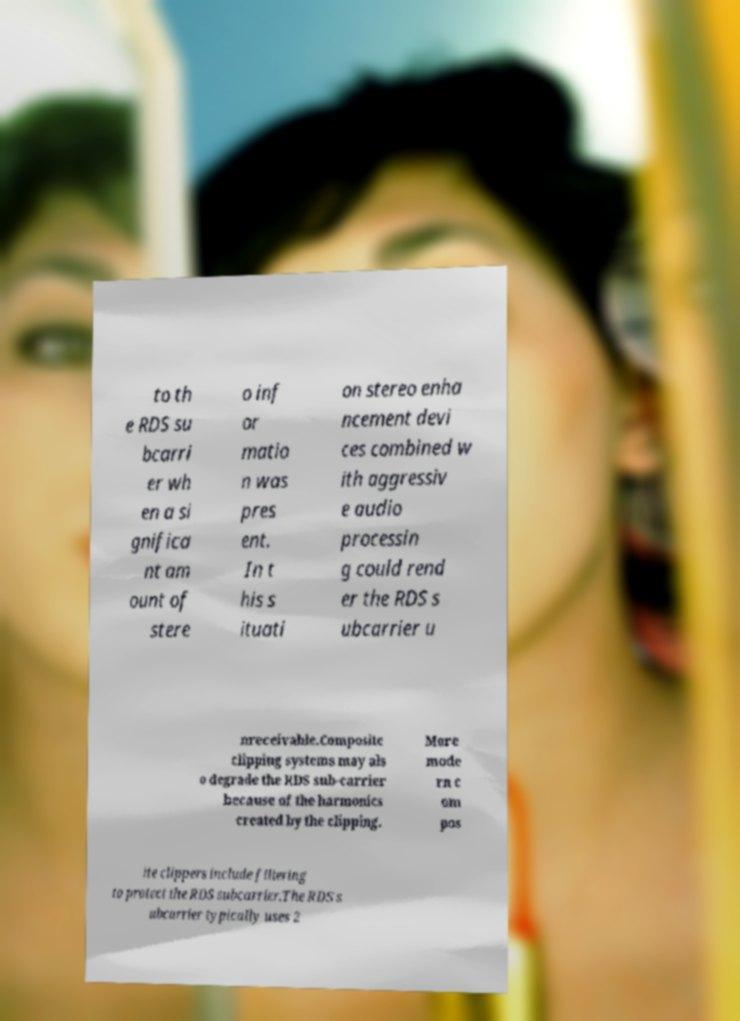What messages or text are displayed in this image? I need them in a readable, typed format. to th e RDS su bcarri er wh en a si gnifica nt am ount of stere o inf or matio n was pres ent. In t his s ituati on stereo enha ncement devi ces combined w ith aggressiv e audio processin g could rend er the RDS s ubcarrier u nreceivable.Composite clipping systems may als o degrade the RDS sub-carrier because of the harmonics created by the clipping. More mode rn c om pos ite clippers include filtering to protect the RDS subcarrier.The RDS s ubcarrier typically uses 2 